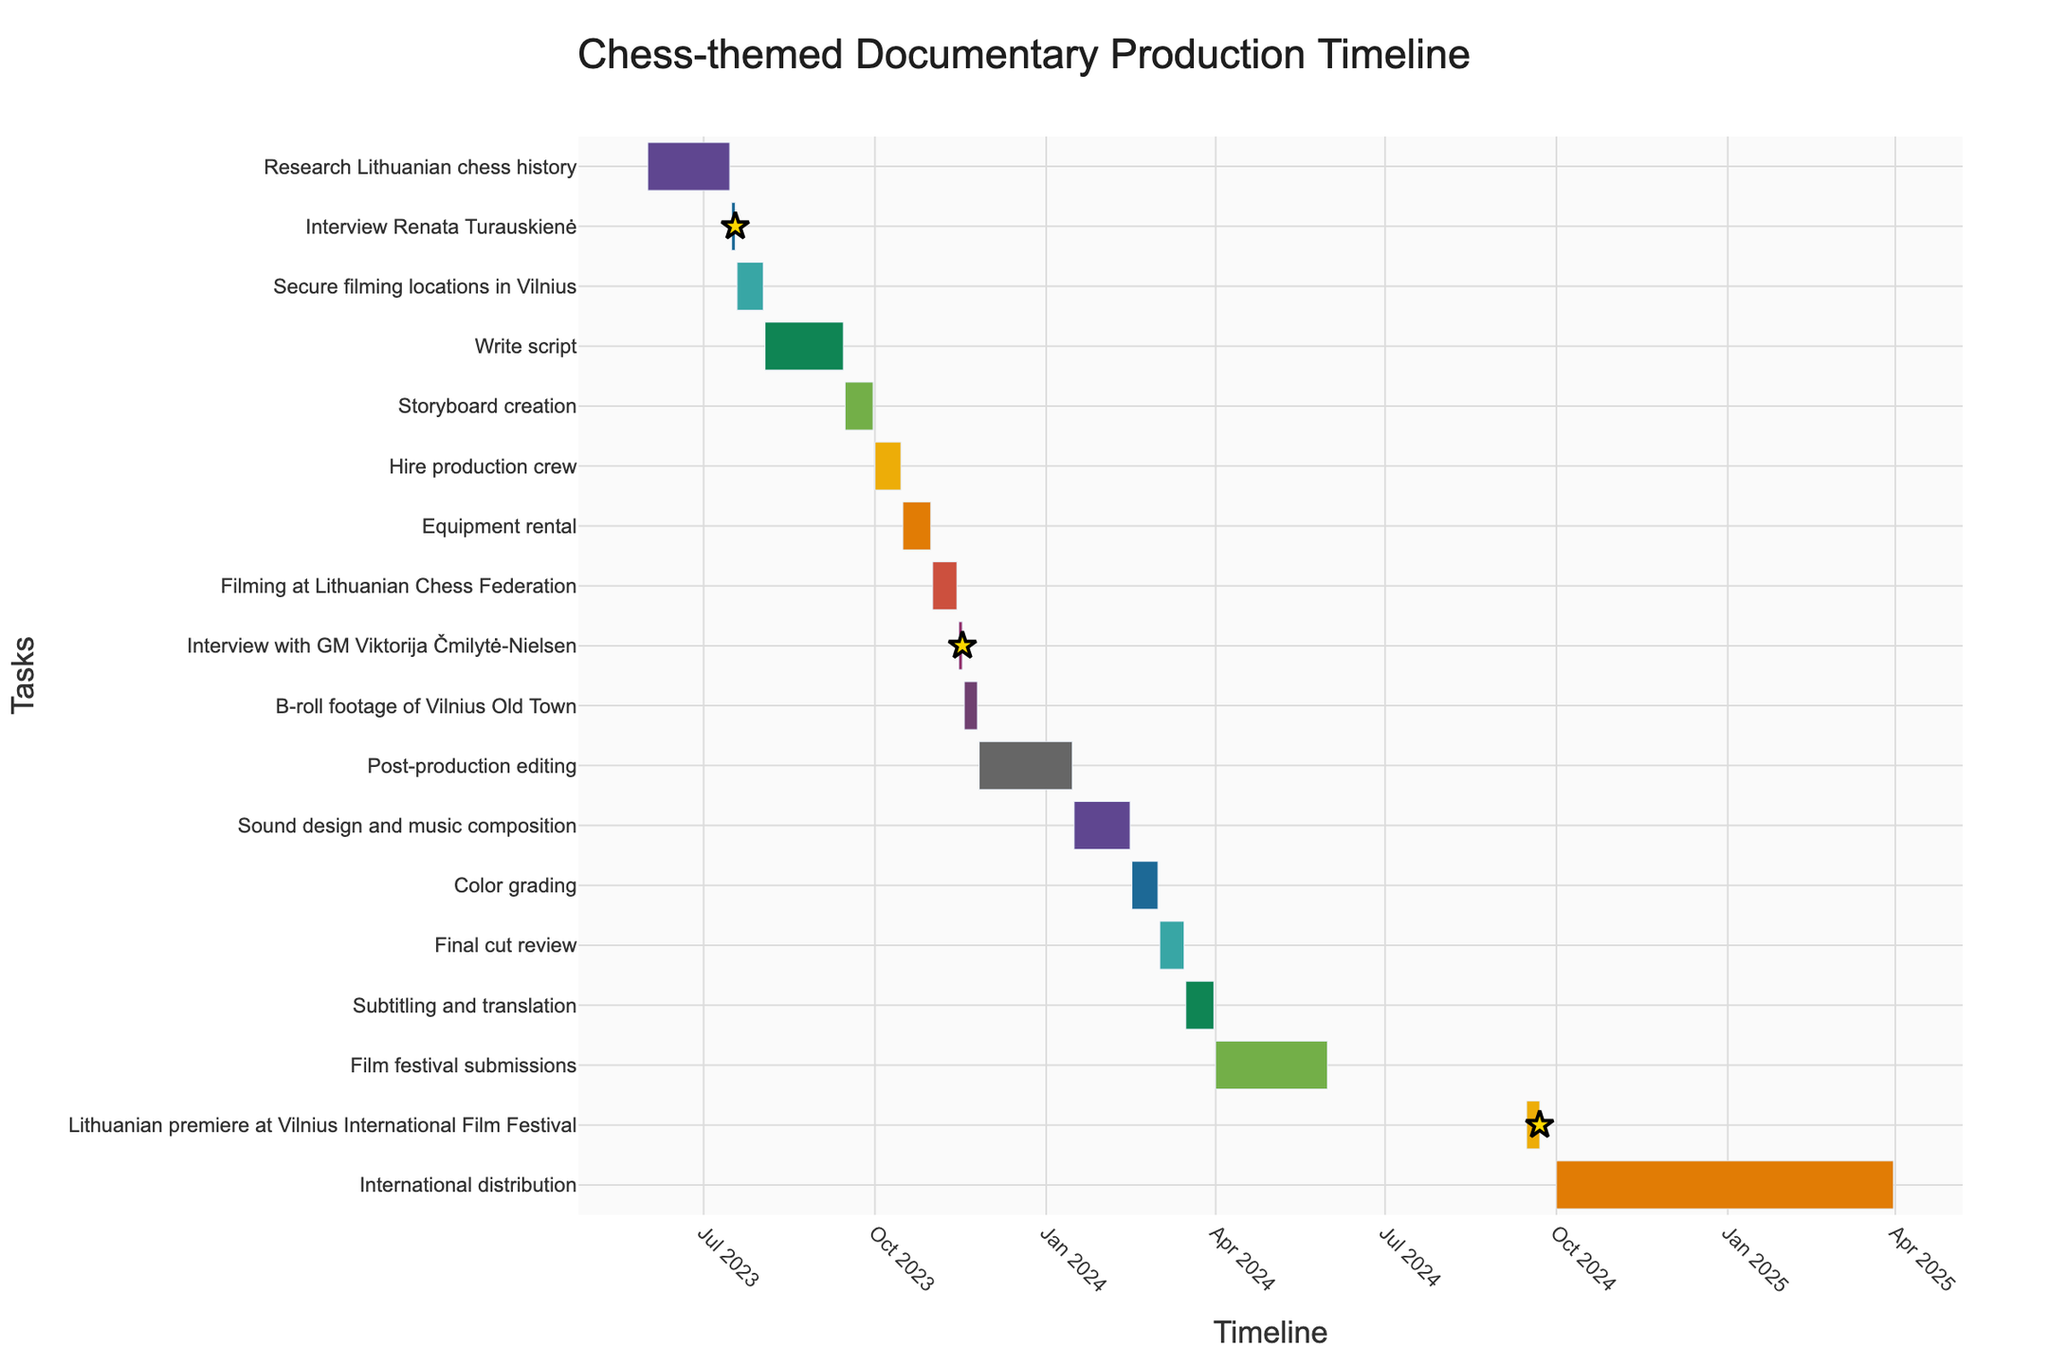What's the title of the Gantt Chart? The title is usually located at the top or the center of the chart. It provides the overall description of the chart content. Here it says "Chess-themed Documentary Production Timeline".
Answer: "Chess-themed Documentary Production Timeline" What is the first task in the timeline? The tasks are listed on the Y-axis (vertical axis) in order of their start dates. The first task listed is "Research Lithuanian chess history".
Answer: "Research Lithuanian chess history" Describe the duration and timeline for the task "Write script". Looking at the chart, locate the "Write script" task on the Y-axis, and trace it horizontally to check the start and end dates. Then, calculate the duration between these dates. The task starts on 2023-08-03 and ends on 2023-09-14, lasting for 43 days.
Answer: 08/03/2023 to 09/14/2023, Duration: 43 days Which tasks have star markers indicating milestones? Star markers are visual indicators used to highlight key milestones in the chart. Identify the tasks with these special markers. They are "Interview Renata Turauskienė", "Interview with GM Viktorija Čmilytė-Nielsen", and "Lithuanian premiere at Vilnius International Film Festival".
Answer: "Interview Renata Turauskienė", "Interview with GM Viktorija Čmilytė-Nielsen", "Lithuanian premiere at Vilnius International Film Festival" What tasks occur in November 2023? To answer this, find the tasks that overlap with November 2023 by tracking their start and end dates. The tasks in November 2023 are "Filming at Lithuanian Chess Federation", "Interview with GM Viktorija Čmilytė-Nielsen", "B-roll footage of Vilnius Old Town", and "Post-production editing".
Answer: "Filming at Lithuanian Chess Federation", "Interview with GM Viktorija Čmilytė-Nielsen", "B-roll footage of Vilnius Old Town", "Post-production editing" How long does the post-production editing take? Locate the "Post-production editing" task on the Y-axis, track its start and end dates on the X-axis, and subtract the start date from the end date to find the duration. The task starts on 2023-11-26 and ends on 2024-01-15, lasting for 51 days.
Answer: 51 days Which is longer, the script writing or the storyboarding process? Compare the durations of the "Write script" and "Storyboard creation" tasks by checking the number of days each task spans. The script writing takes 43 days, while the storyboard creation takes 15 days. Thus, script writing is longer.
Answer: Script writing When does the Lithuanian premiere at the Vilnius International Film Festival take place? Locate the task "Lithuanian premiere at Vilnius International Film Festival" on the Y-axis, then trace it horizontally to find the start and end dates. The premiere occurs from 2024-09-15 to 2024-09-22.
Answer: 09/15/2024 to 09/22/2024 What is the longest task in the production timeline? To determine the longest task, compare the durations of all tasks listed by measuring the length of each horizontal bar. The task "International distribution" has the longest duration, from 2024-10-01 to 2025-03-31, which is 182 days.
Answer: "International distribution", 182 days 